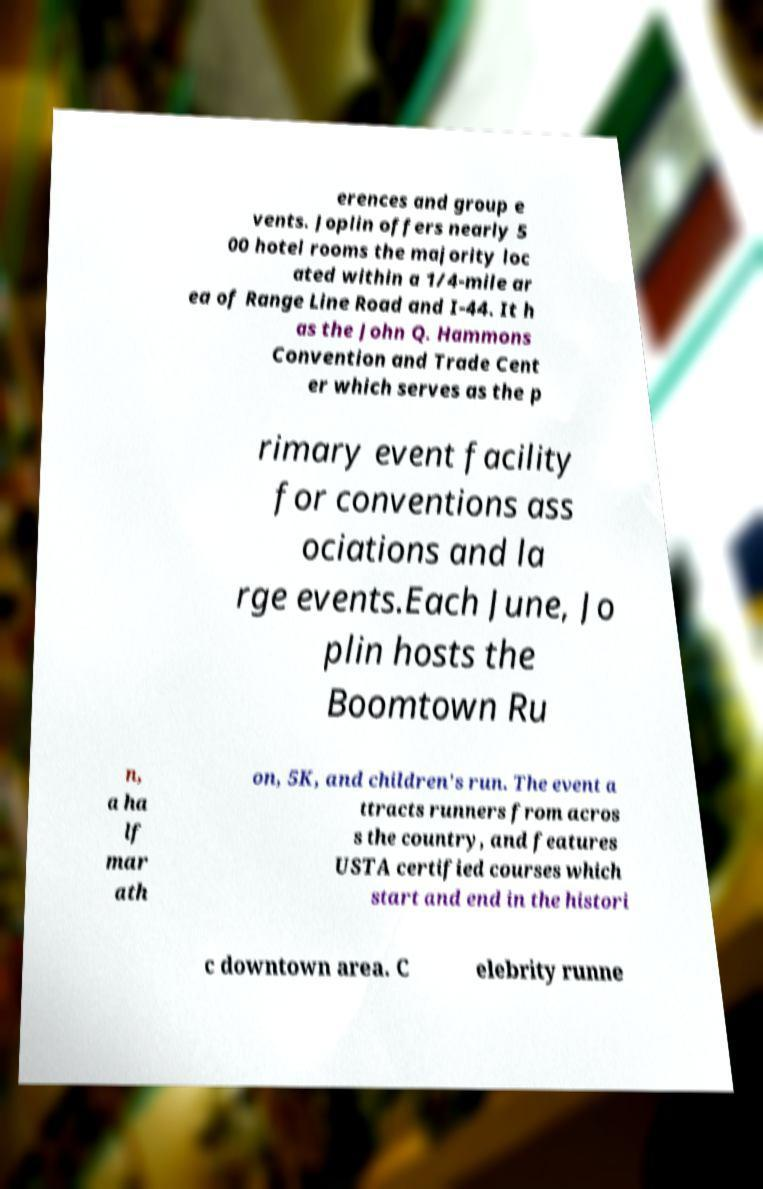Please identify and transcribe the text found in this image. erences and group e vents. Joplin offers nearly 5 00 hotel rooms the majority loc ated within a 1/4-mile ar ea of Range Line Road and I-44. It h as the John Q. Hammons Convention and Trade Cent er which serves as the p rimary event facility for conventions ass ociations and la rge events.Each June, Jo plin hosts the Boomtown Ru n, a ha lf mar ath on, 5K, and children's run. The event a ttracts runners from acros s the country, and features USTA certified courses which start and end in the histori c downtown area. C elebrity runne 